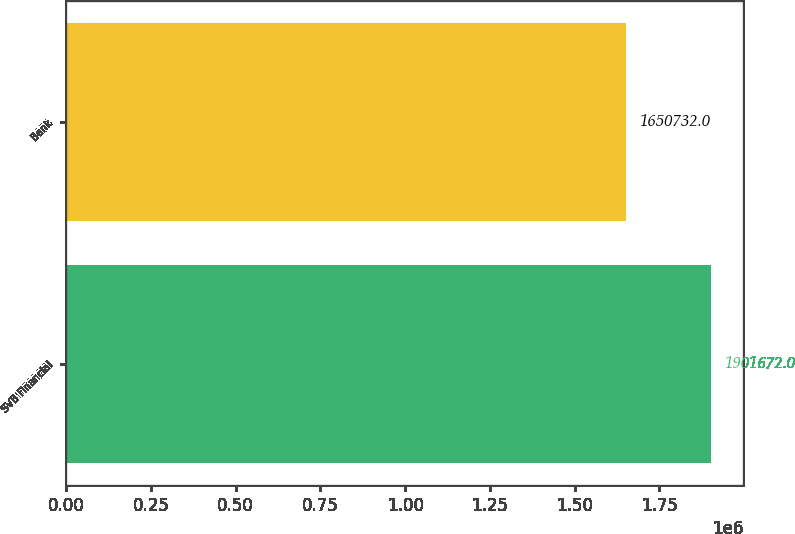Convert chart to OTSL. <chart><loc_0><loc_0><loc_500><loc_500><bar_chart><fcel>SVB Financial<fcel>Bank<nl><fcel>1.90167e+06<fcel>1.65073e+06<nl></chart> 